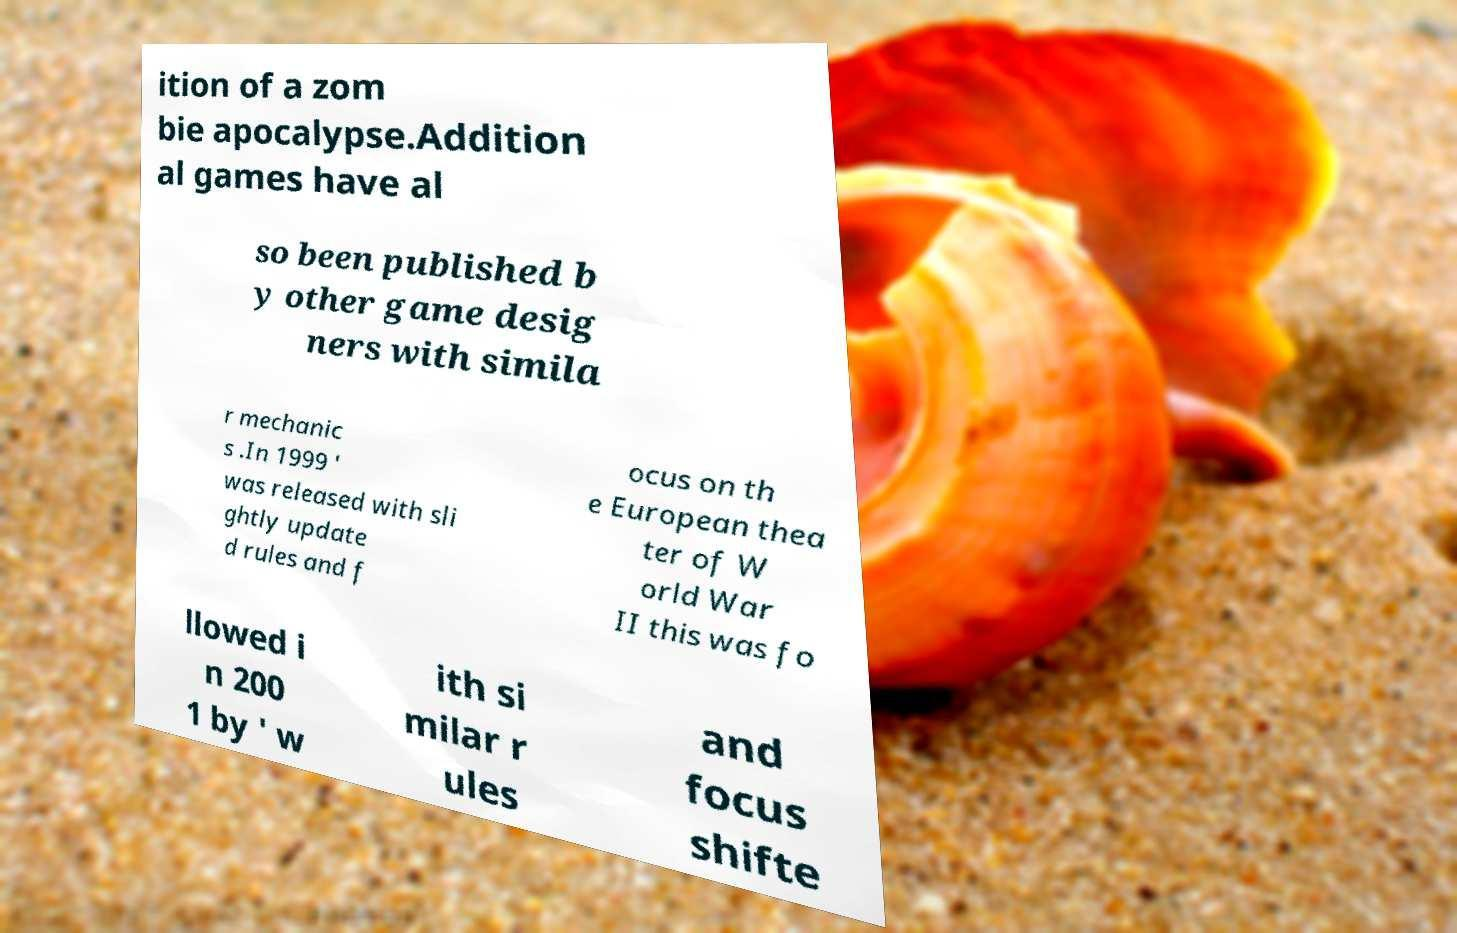Please read and relay the text visible in this image. What does it say? ition of a zom bie apocalypse.Addition al games have al so been published b y other game desig ners with simila r mechanic s .In 1999 ' was released with sli ghtly update d rules and f ocus on th e European thea ter of W orld War II this was fo llowed i n 200 1 by ' w ith si milar r ules and focus shifte 